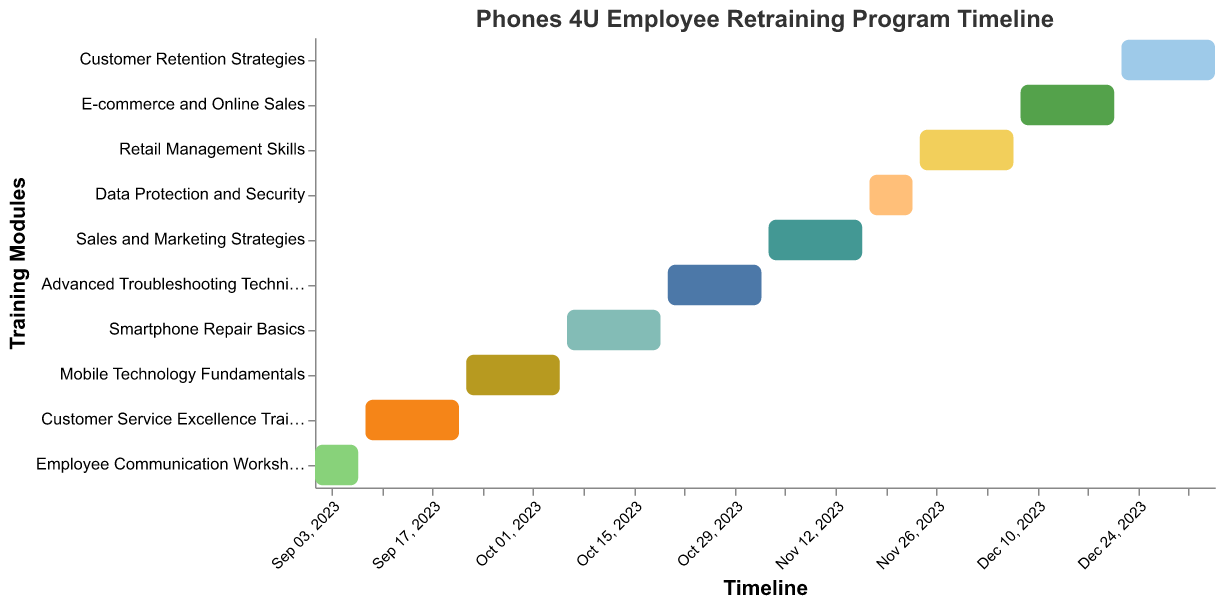What is the first training module in the program? According to the Gantt Chart, the first training module listed at the top with the earliest start date is the "Employee Communication Workshop."
Answer: Employee Communication Workshop How many total training modules are there in the retraining program? The Gantt Chart lists each separate task as a different training module. Counting the bars represents the total number of training modules, which is 10.
Answer: 10 Which training module has the longest duration? The length of each bar represents the duration. By comparing the lengths of the bars visually, "Customer Service Excellence Training" and "Retail Management Skills" have the longest durations, each spanning approximately two weeks.
Answer: Customer Service Excellence Training, Retail Management Skills How many days does the "Smartphone Repair Basics" module last? Look at the start and end dates for "Smartphone Repair Basics" on the Gantt Chart. The start date is 2023-10-06, and the end date is 2023-10-19. Counting the days inclusive, it spans 14 days.
Answer: 14 days Which training module ends right before "Sales and Marketing Strategies" starts? Identify the end date of the module just before the start date of "Sales and Marketing Strategies." The previous module, "Advanced Troubleshooting Techniques," ends on 2023-11-02, while "Sales and Marketing Strategies" starts on 2023-11-03.
Answer: Advanced Troubleshooting Techniques What is the duration of the entire retraining program? The entire duration is from the start date of the first module to the end date of the last module. The start date of "Employee Communication Workshop" is 2023-09-01, and the end date of "Customer Retention Strategies" is 2024-01-04. Calculating the number of days between these dates gives 126 days.
Answer: 126 days How does the duration of the "E-commerce and Online Sales" module compare to the "Customer Retention Strategies" module? Compare the start and end dates of both modules. "E-commerce and Online Sales" spans from 2023-12-08 to 2023-12-21 (14 days), while "Customer Retention Strategies" spans from 2023-12-22 to 2024-01-04 (14 days). Both modules have the same duration of 14 days.
Answer: Both are 14 days Which month has the most training modules occurring? Identify all start and end dates falling within each month. September (3 modules), October (2 modules), November (3 modules), and December (2 modules) have training modules. The month with the maximum is September.
Answer: September Does any module start before the previous one ends? Review the end date of each module and the start date of the subsequent module. Each module starts the day after the previous module ends with no overlap.
Answer: No Are there any breaks between the training modules? Examining the end and subsequent start dates of all modules reveals that each module starts immediately following the end of the previous module, indicating no breaks.
Answer: No 